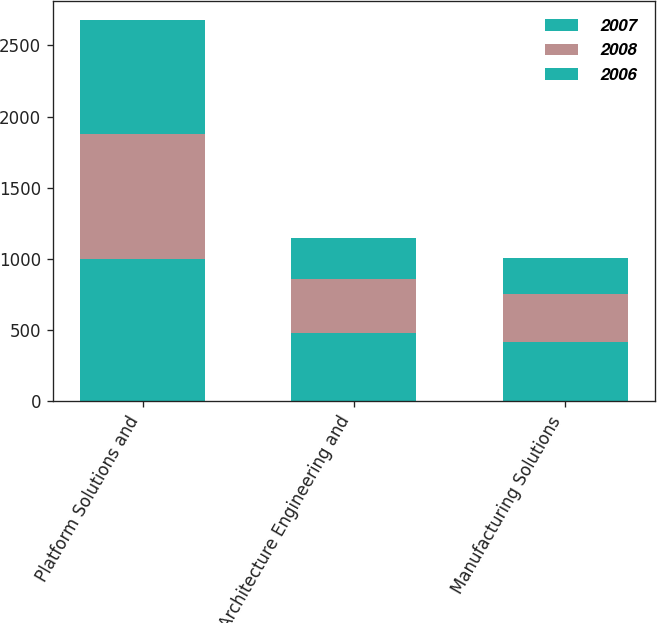<chart> <loc_0><loc_0><loc_500><loc_500><stacked_bar_chart><ecel><fcel>Platform Solutions and<fcel>Architecture Engineering and<fcel>Manufacturing Solutions<nl><fcel>2007<fcel>997.1<fcel>480<fcel>418<nl><fcel>2008<fcel>878.9<fcel>382.4<fcel>333.3<nl><fcel>2006<fcel>803.3<fcel>284.3<fcel>256.9<nl></chart> 